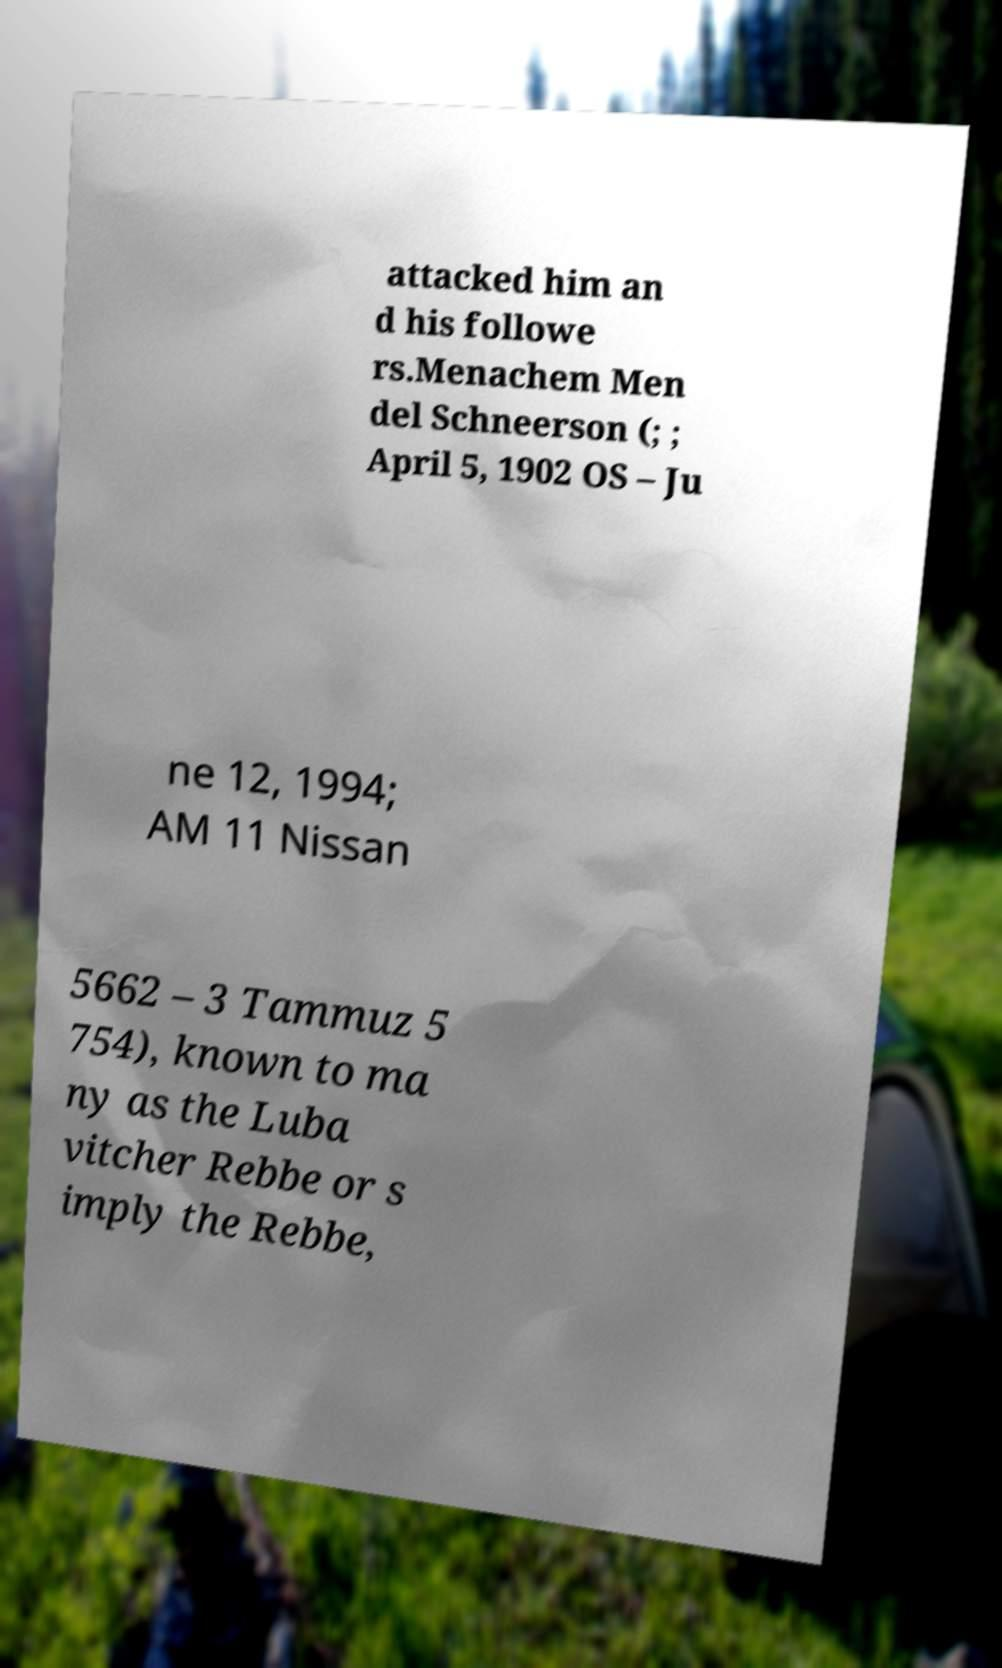Could you assist in decoding the text presented in this image and type it out clearly? attacked him an d his followe rs.Menachem Men del Schneerson (; ; April 5, 1902 OS – Ju ne 12, 1994; AM 11 Nissan 5662 – 3 Tammuz 5 754), known to ma ny as the Luba vitcher Rebbe or s imply the Rebbe, 